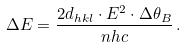<formula> <loc_0><loc_0><loc_500><loc_500>\Delta E = \frac { 2 d _ { h k l } \cdot E ^ { 2 } \cdot \Delta \theta _ { B } } { n h c } \, .</formula> 